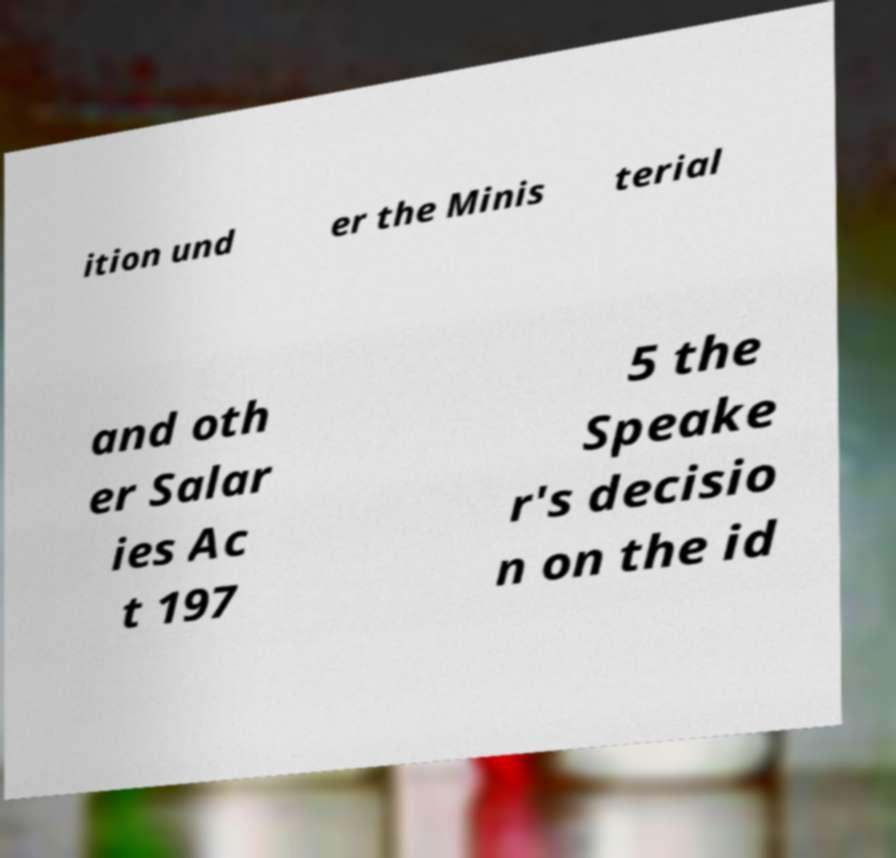Please identify and transcribe the text found in this image. ition und er the Minis terial and oth er Salar ies Ac t 197 5 the Speake r's decisio n on the id 